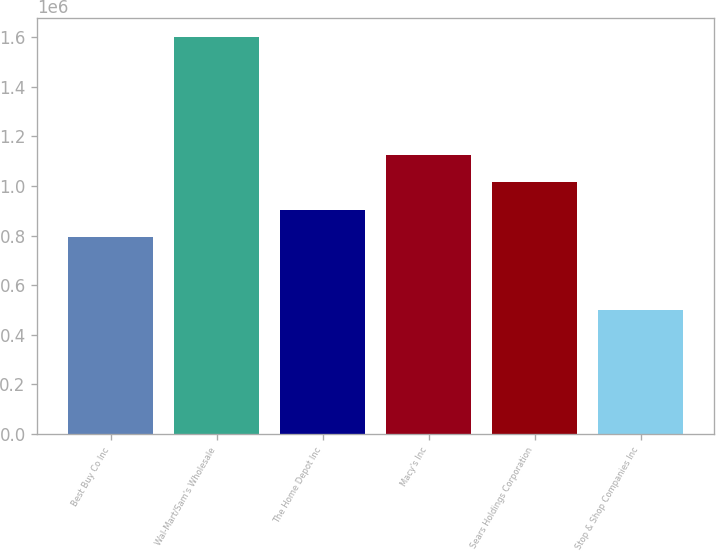Convert chart to OTSL. <chart><loc_0><loc_0><loc_500><loc_500><bar_chart><fcel>Best Buy Co Inc<fcel>Wal-Mart/Sam's Wholesale<fcel>The Home Depot Inc<fcel>Macy's Inc<fcel>Sears Holdings Corporation<fcel>Stop & Shop Companies Inc<nl><fcel>795000<fcel>1.599e+06<fcel>905100<fcel>1.1253e+06<fcel>1.0152e+06<fcel>498000<nl></chart> 